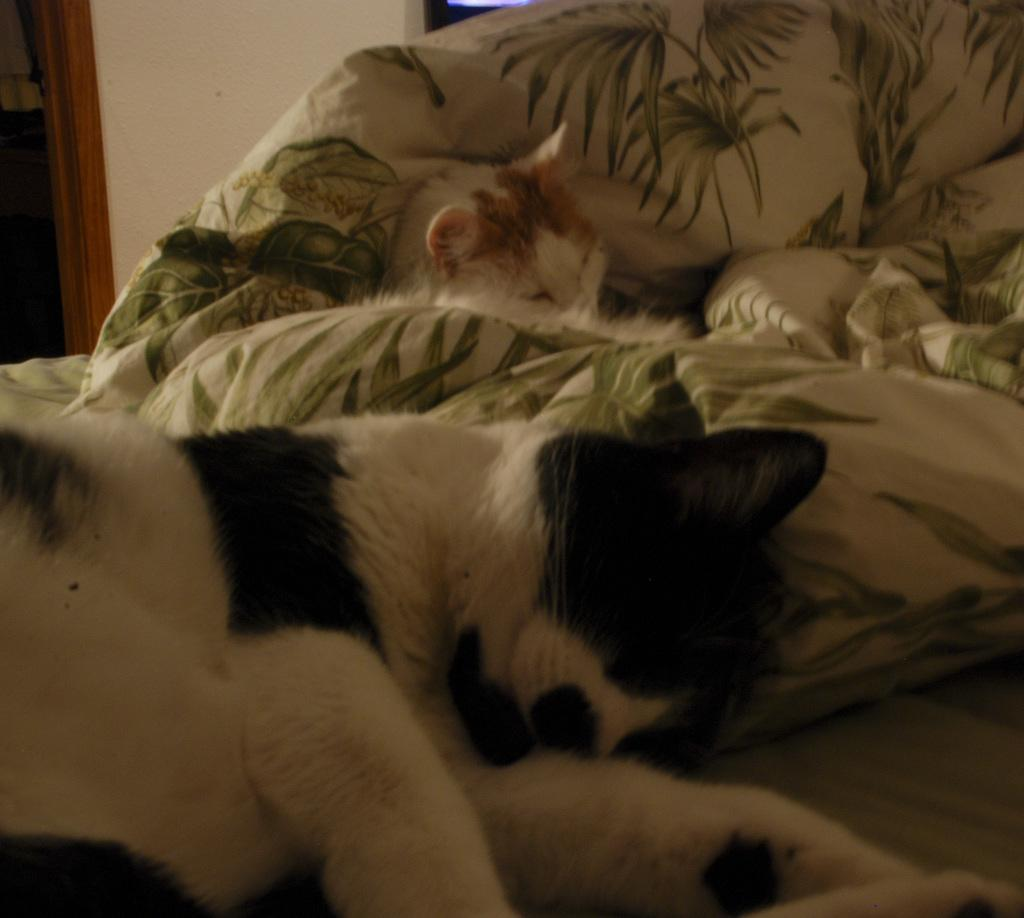What animals can be seen in the image? There is a dog and a cat in the image. What are the animals doing in the image? Both the dog and cat are sleeping on the bed. What can be seen in the background of the image? There is a wall and a wooden door frame in the background of the image. What type of coat is the bear wearing in the image? There is no bear present in the image, and therefore no coat can be observed. What order are the animals arranged in the image? The animals are not arranged in any specific order; they are both sleeping on the bed. 